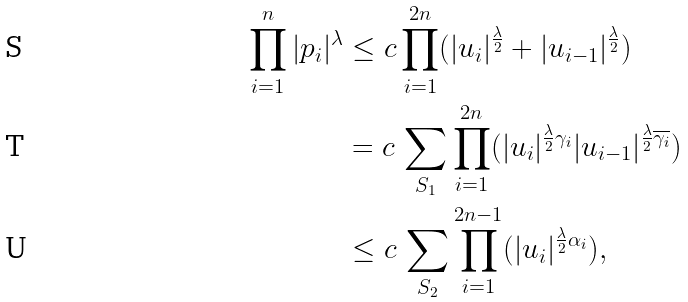Convert formula to latex. <formula><loc_0><loc_0><loc_500><loc_500>\prod _ { i = 1 } ^ { n } | p _ { i } | ^ { \lambda } & \leq c \prod _ { i = 1 } ^ { 2 n } ( | u _ { i } | ^ { \frac { \lambda } 2 } + | u _ { i - 1 } | ^ { \frac { \lambda } 2 } ) \\ & = c \, \sum _ { S _ { 1 } } \prod _ { i = 1 } ^ { 2 n } ( | u _ { i } | ^ { \frac { \lambda } 2 \gamma _ { i } } | u _ { i - 1 } | ^ { \frac { \lambda } 2 \overline { \gamma _ { i } } } ) \\ & \leq c \, \sum _ { S _ { 2 } } \prod _ { i = 1 } ^ { 2 n - 1 } ( | u _ { i } | ^ { \frac { \lambda } 2 \alpha _ { i } } ) ,</formula> 